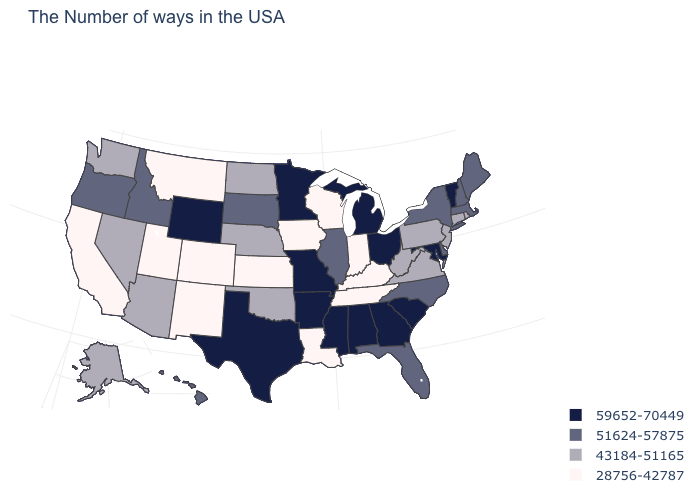Name the states that have a value in the range 51624-57875?
Answer briefly. Maine, Massachusetts, New Hampshire, New York, Delaware, North Carolina, Florida, Illinois, South Dakota, Idaho, Oregon, Hawaii. What is the value of Rhode Island?
Short answer required. 43184-51165. What is the value of Maine?
Be succinct. 51624-57875. Name the states that have a value in the range 43184-51165?
Quick response, please. Rhode Island, Connecticut, New Jersey, Pennsylvania, Virginia, West Virginia, Nebraska, Oklahoma, North Dakota, Arizona, Nevada, Washington, Alaska. What is the value of Mississippi?
Write a very short answer. 59652-70449. What is the highest value in the MidWest ?
Keep it brief. 59652-70449. Does Louisiana have the lowest value in the USA?
Answer briefly. Yes. Name the states that have a value in the range 59652-70449?
Quick response, please. Vermont, Maryland, South Carolina, Ohio, Georgia, Michigan, Alabama, Mississippi, Missouri, Arkansas, Minnesota, Texas, Wyoming. Among the states that border Arizona , does Colorado have the lowest value?
Short answer required. Yes. Does Louisiana have the lowest value in the South?
Quick response, please. Yes. Among the states that border Washington , which have the lowest value?
Keep it brief. Idaho, Oregon. What is the lowest value in states that border Missouri?
Quick response, please. 28756-42787. What is the value of New Jersey?
Concise answer only. 43184-51165. What is the value of Illinois?
Write a very short answer. 51624-57875. 